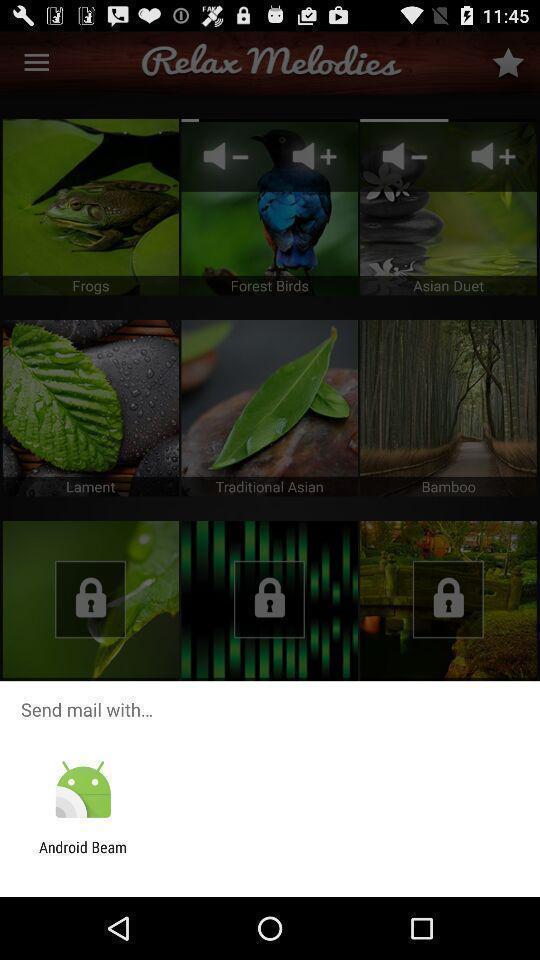What is the overall content of this screenshot? Sending mail using the operating system. 